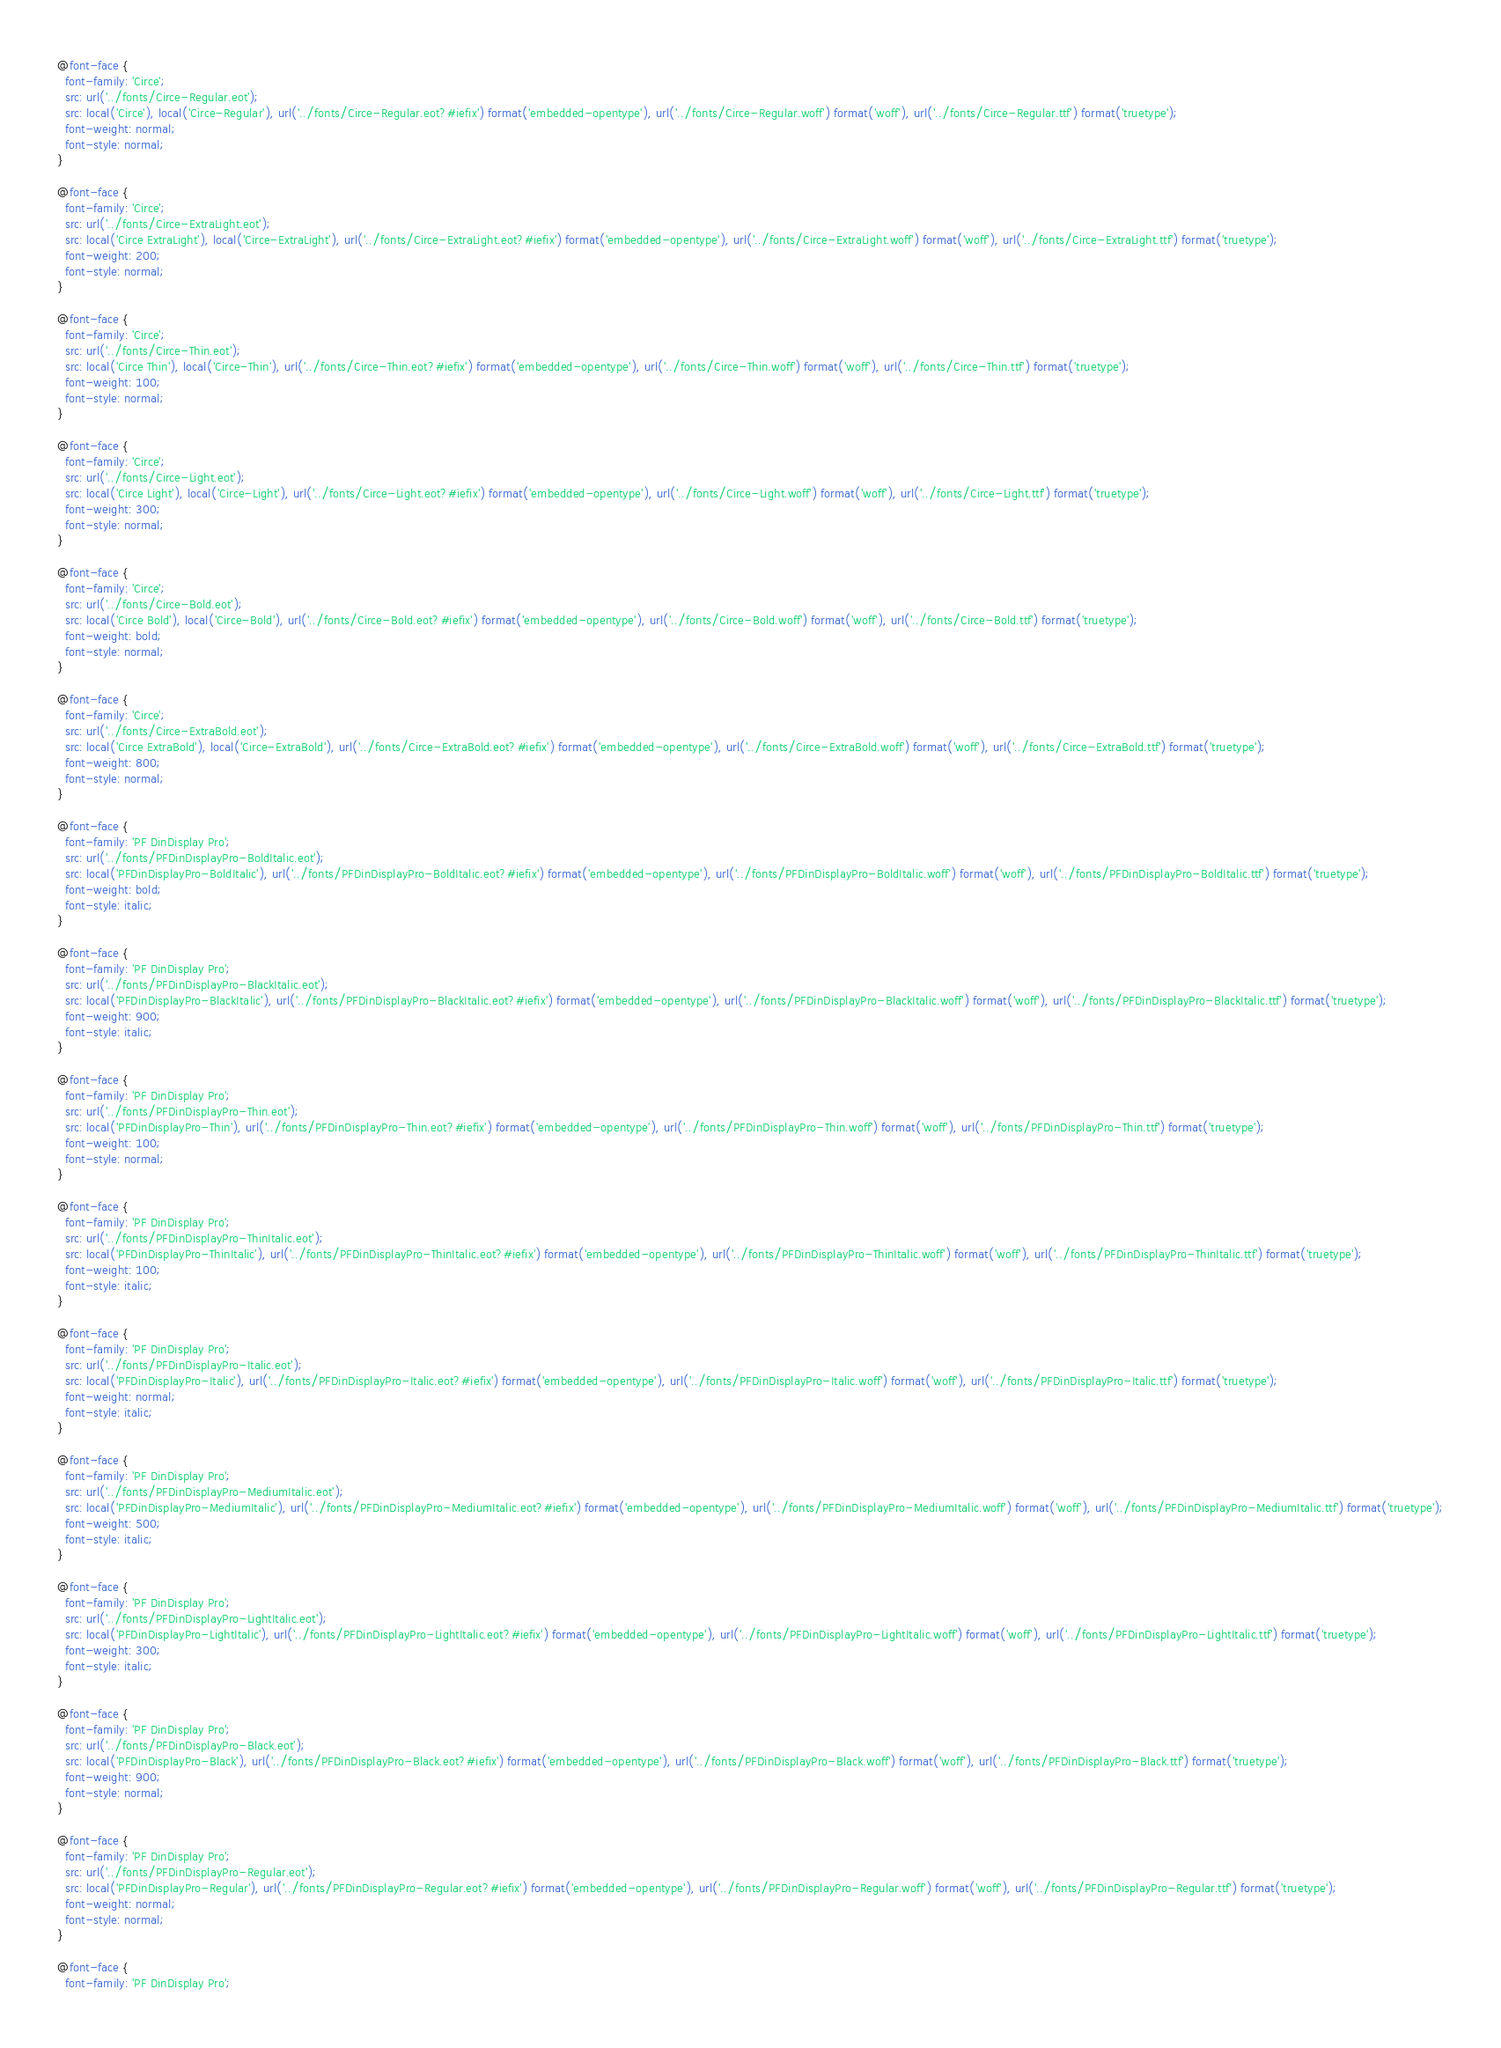Convert code to text. <code><loc_0><loc_0><loc_500><loc_500><_CSS_>@font-face {
  font-family: 'Circe';
  src: url('../fonts/Circe-Regular.eot');
  src: local('Circe'), local('Circe-Regular'), url('../fonts/Circe-Regular.eot?#iefix') format('embedded-opentype'), url('../fonts/Circe-Regular.woff') format('woff'), url('../fonts/Circe-Regular.ttf') format('truetype');
  font-weight: normal;
  font-style: normal;
}

@font-face {
  font-family: 'Circe';
  src: url('../fonts/Circe-ExtraLight.eot');
  src: local('Circe ExtraLight'), local('Circe-ExtraLight'), url('../fonts/Circe-ExtraLight.eot?#iefix') format('embedded-opentype'), url('../fonts/Circe-ExtraLight.woff') format('woff'), url('../fonts/Circe-ExtraLight.ttf') format('truetype');
  font-weight: 200;
  font-style: normal;
}

@font-face {
  font-family: 'Circe';
  src: url('../fonts/Circe-Thin.eot');
  src: local('Circe Thin'), local('Circe-Thin'), url('../fonts/Circe-Thin.eot?#iefix') format('embedded-opentype'), url('../fonts/Circe-Thin.woff') format('woff'), url('../fonts/Circe-Thin.ttf') format('truetype');
  font-weight: 100;
  font-style: normal;
}

@font-face {
  font-family: 'Circe';
  src: url('../fonts/Circe-Light.eot');
  src: local('Circe Light'), local('Circe-Light'), url('../fonts/Circe-Light.eot?#iefix') format('embedded-opentype'), url('../fonts/Circe-Light.woff') format('woff'), url('../fonts/Circe-Light.ttf') format('truetype');
  font-weight: 300;
  font-style: normal;
}

@font-face {
  font-family: 'Circe';
  src: url('../fonts/Circe-Bold.eot');
  src: local('Circe Bold'), local('Circe-Bold'), url('../fonts/Circe-Bold.eot?#iefix') format('embedded-opentype'), url('../fonts/Circe-Bold.woff') format('woff'), url('../fonts/Circe-Bold.ttf') format('truetype');
  font-weight: bold;
  font-style: normal;
}

@font-face {
  font-family: 'Circe';
  src: url('../fonts/Circe-ExtraBold.eot');
  src: local('Circe ExtraBold'), local('Circe-ExtraBold'), url('../fonts/Circe-ExtraBold.eot?#iefix') format('embedded-opentype'), url('../fonts/Circe-ExtraBold.woff') format('woff'), url('../fonts/Circe-ExtraBold.ttf') format('truetype');
  font-weight: 800;
  font-style: normal;
}

@font-face {
  font-family: 'PF DinDisplay Pro';
  src: url('../fonts/PFDinDisplayPro-BoldItalic.eot');
  src: local('PFDinDisplayPro-BoldItalic'), url('../fonts/PFDinDisplayPro-BoldItalic.eot?#iefix') format('embedded-opentype'), url('../fonts/PFDinDisplayPro-BoldItalic.woff') format('woff'), url('../fonts/PFDinDisplayPro-BoldItalic.ttf') format('truetype');
  font-weight: bold;
  font-style: italic;
}

@font-face {
  font-family: 'PF DinDisplay Pro';
  src: url('../fonts/PFDinDisplayPro-BlackItalic.eot');
  src: local('PFDinDisplayPro-BlackItalic'), url('../fonts/PFDinDisplayPro-BlackItalic.eot?#iefix') format('embedded-opentype'), url('../fonts/PFDinDisplayPro-BlackItalic.woff') format('woff'), url('../fonts/PFDinDisplayPro-BlackItalic.ttf') format('truetype');
  font-weight: 900;
  font-style: italic;
}

@font-face {
  font-family: 'PF DinDisplay Pro';
  src: url('../fonts/PFDinDisplayPro-Thin.eot');
  src: local('PFDinDisplayPro-Thin'), url('../fonts/PFDinDisplayPro-Thin.eot?#iefix') format('embedded-opentype'), url('../fonts/PFDinDisplayPro-Thin.woff') format('woff'), url('../fonts/PFDinDisplayPro-Thin.ttf') format('truetype');
  font-weight: 100;
  font-style: normal;
}

@font-face {
  font-family: 'PF DinDisplay Pro';
  src: url('../fonts/PFDinDisplayPro-ThinItalic.eot');
  src: local('PFDinDisplayPro-ThinItalic'), url('../fonts/PFDinDisplayPro-ThinItalic.eot?#iefix') format('embedded-opentype'), url('../fonts/PFDinDisplayPro-ThinItalic.woff') format('woff'), url('../fonts/PFDinDisplayPro-ThinItalic.ttf') format('truetype');
  font-weight: 100;
  font-style: italic;
}

@font-face {
  font-family: 'PF DinDisplay Pro';
  src: url('../fonts/PFDinDisplayPro-Italic.eot');
  src: local('PFDinDisplayPro-Italic'), url('../fonts/PFDinDisplayPro-Italic.eot?#iefix') format('embedded-opentype'), url('../fonts/PFDinDisplayPro-Italic.woff') format('woff'), url('../fonts/PFDinDisplayPro-Italic.ttf') format('truetype');
  font-weight: normal;
  font-style: italic;
}

@font-face {
  font-family: 'PF DinDisplay Pro';
  src: url('../fonts/PFDinDisplayPro-MediumItalic.eot');
  src: local('PFDinDisplayPro-MediumItalic'), url('../fonts/PFDinDisplayPro-MediumItalic.eot?#iefix') format('embedded-opentype'), url('../fonts/PFDinDisplayPro-MediumItalic.woff') format('woff'), url('../fonts/PFDinDisplayPro-MediumItalic.ttf') format('truetype');
  font-weight: 500;
  font-style: italic;
}

@font-face {
  font-family: 'PF DinDisplay Pro';
  src: url('../fonts/PFDinDisplayPro-LightItalic.eot');
  src: local('PFDinDisplayPro-LightItalic'), url('../fonts/PFDinDisplayPro-LightItalic.eot?#iefix') format('embedded-opentype'), url('../fonts/PFDinDisplayPro-LightItalic.woff') format('woff'), url('../fonts/PFDinDisplayPro-LightItalic.ttf') format('truetype');
  font-weight: 300;
  font-style: italic;
}

@font-face {
  font-family: 'PF DinDisplay Pro';
  src: url('../fonts/PFDinDisplayPro-Black.eot');
  src: local('PFDinDisplayPro-Black'), url('../fonts/PFDinDisplayPro-Black.eot?#iefix') format('embedded-opentype'), url('../fonts/PFDinDisplayPro-Black.woff') format('woff'), url('../fonts/PFDinDisplayPro-Black.ttf') format('truetype');
  font-weight: 900;
  font-style: normal;
}

@font-face {
  font-family: 'PF DinDisplay Pro';
  src: url('../fonts/PFDinDisplayPro-Regular.eot');
  src: local('PFDinDisplayPro-Regular'), url('../fonts/PFDinDisplayPro-Regular.eot?#iefix') format('embedded-opentype'), url('../fonts/PFDinDisplayPro-Regular.woff') format('woff'), url('../fonts/PFDinDisplayPro-Regular.ttf') format('truetype');
  font-weight: normal;
  font-style: normal;
}

@font-face {
  font-family: 'PF DinDisplay Pro';</code> 